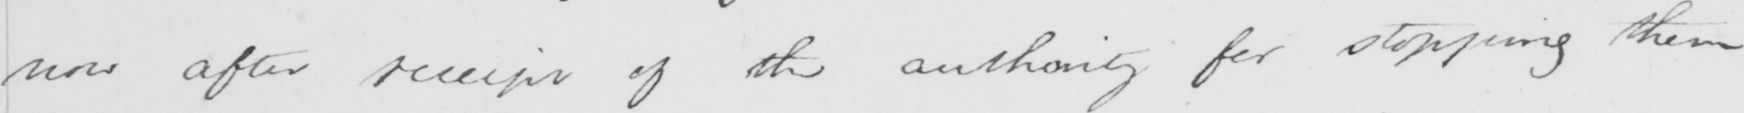Can you read and transcribe this handwriting? now after receipt of the authority for stopping them 